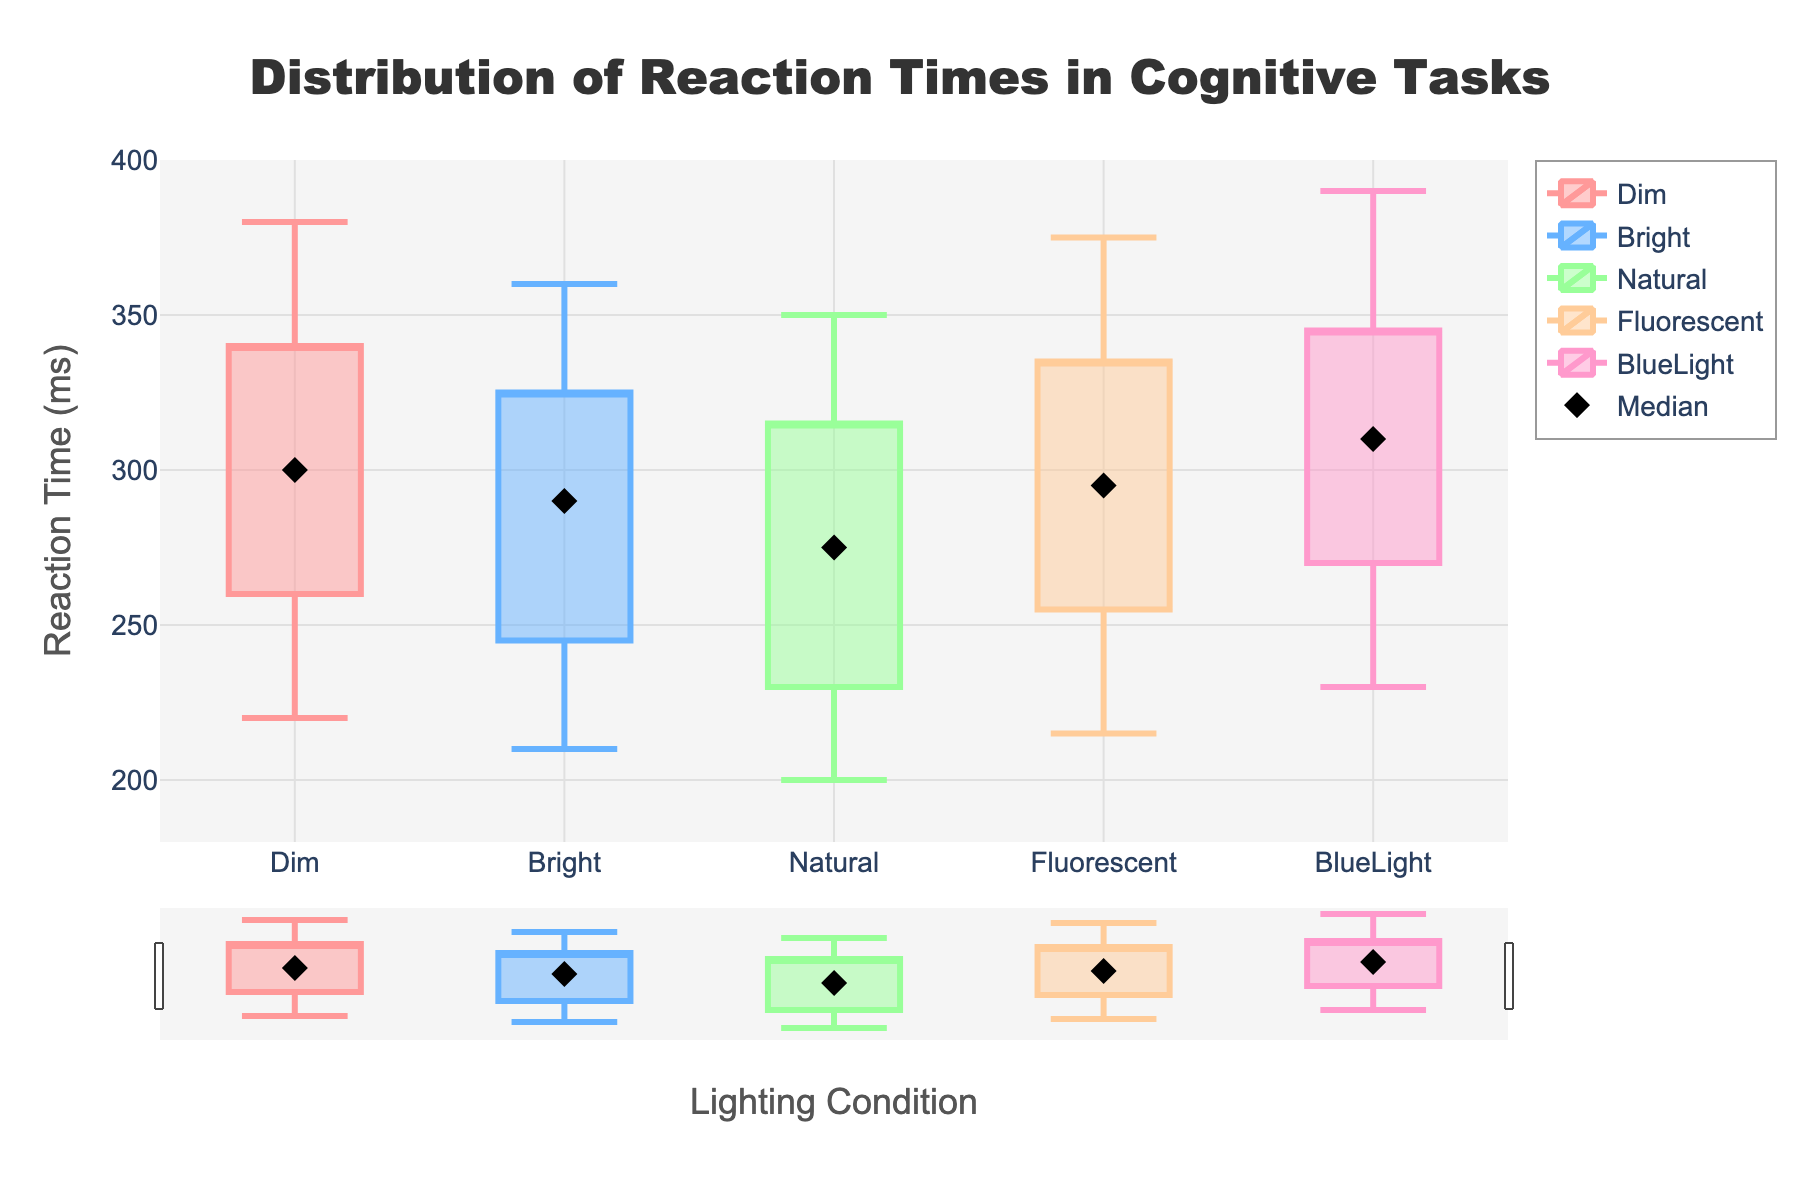what is the title of the plot? The title is displayed at the top center of the plot. It reads "Distribution of Reaction Times in Cognitive Tasks."
Answer: Distribution of Reaction Times in Cognitive Tasks what is the reaction time range for the 'Dim' lighting condition? The range is indicated by the minimum and maximum reaction times for the 'Dim' condition, which are the lowest and highest points of the candlestick. For 'Dim', the minimum is 220 ms and the maximum is 380 ms.
Answer: 220-380 ms which lighting condition has the highest median reaction time? The median reaction time for each lighting condition is represented by the diamond markers. The 'BlueLight' condition has the highest median at 310 ms.
Answer: BlueLight by how many milliseconds is the third quartile of 'Natural' lower than 'Fluorescent'? Locate the third quartile (top edge of the rectangular box) for both conditions. 'Natural' is 315 ms, and 'Fluorescent' is 335 ms. The difference is 335 ms - 315 ms = 20 ms.
Answer: 20 ms which lighting condition has the narrowest range of reaction times? The range is the difference between the maximum and minimum reaction times for each condition. 'Natural' ranges from 200 ms to 350 ms, so the total range is 150 ms. This is the smallest range among all conditions.
Answer: Natural what is the median reaction time for the 'Bright' lighting condition? The median for each condition is marked by the diamond marker. For 'Bright', the median reaction time is 290 ms.
Answer: 290 ms which condition shows the minimum reaction time overall? The minimum reaction time is the lowest point of the candlesticks. 'Natural' condition shows the lowest minimum reaction time at 200 ms.
Answer: Natural 